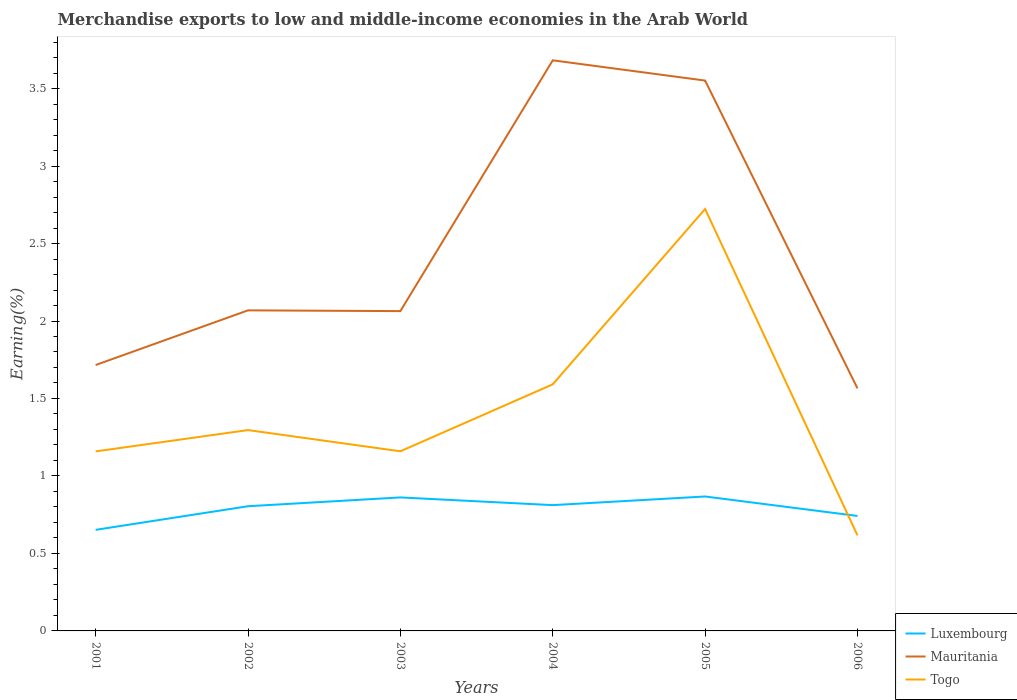How many different coloured lines are there?
Your response must be concise. 3. Does the line corresponding to Luxembourg intersect with the line corresponding to Togo?
Offer a terse response. Yes. Is the number of lines equal to the number of legend labels?
Your answer should be very brief. Yes. Across all years, what is the maximum percentage of amount earned from merchandise exports in Togo?
Your response must be concise. 0.62. What is the total percentage of amount earned from merchandise exports in Luxembourg in the graph?
Give a very brief answer. -0.06. What is the difference between the highest and the second highest percentage of amount earned from merchandise exports in Togo?
Make the answer very short. 2.11. Is the percentage of amount earned from merchandise exports in Mauritania strictly greater than the percentage of amount earned from merchandise exports in Luxembourg over the years?
Keep it short and to the point. No. What is the difference between two consecutive major ticks on the Y-axis?
Give a very brief answer. 0.5. Does the graph contain any zero values?
Make the answer very short. No. Where does the legend appear in the graph?
Offer a very short reply. Bottom right. What is the title of the graph?
Make the answer very short. Merchandise exports to low and middle-income economies in the Arab World. Does "St. Kitts and Nevis" appear as one of the legend labels in the graph?
Your response must be concise. No. What is the label or title of the X-axis?
Offer a terse response. Years. What is the label or title of the Y-axis?
Keep it short and to the point. Earning(%). What is the Earning(%) in Luxembourg in 2001?
Provide a succinct answer. 0.65. What is the Earning(%) of Mauritania in 2001?
Offer a terse response. 1.72. What is the Earning(%) of Togo in 2001?
Provide a short and direct response. 1.16. What is the Earning(%) of Luxembourg in 2002?
Keep it short and to the point. 0.8. What is the Earning(%) of Mauritania in 2002?
Your answer should be compact. 2.07. What is the Earning(%) of Togo in 2002?
Your response must be concise. 1.3. What is the Earning(%) in Luxembourg in 2003?
Provide a succinct answer. 0.86. What is the Earning(%) of Mauritania in 2003?
Ensure brevity in your answer.  2.06. What is the Earning(%) in Togo in 2003?
Offer a terse response. 1.16. What is the Earning(%) of Luxembourg in 2004?
Offer a terse response. 0.81. What is the Earning(%) in Mauritania in 2004?
Your answer should be very brief. 3.68. What is the Earning(%) in Togo in 2004?
Offer a terse response. 1.59. What is the Earning(%) in Luxembourg in 2005?
Keep it short and to the point. 0.87. What is the Earning(%) of Mauritania in 2005?
Your answer should be very brief. 3.55. What is the Earning(%) in Togo in 2005?
Offer a very short reply. 2.72. What is the Earning(%) in Luxembourg in 2006?
Provide a succinct answer. 0.74. What is the Earning(%) of Mauritania in 2006?
Give a very brief answer. 1.57. What is the Earning(%) of Togo in 2006?
Offer a very short reply. 0.62. Across all years, what is the maximum Earning(%) of Luxembourg?
Give a very brief answer. 0.87. Across all years, what is the maximum Earning(%) of Mauritania?
Your answer should be compact. 3.68. Across all years, what is the maximum Earning(%) of Togo?
Provide a short and direct response. 2.72. Across all years, what is the minimum Earning(%) of Luxembourg?
Give a very brief answer. 0.65. Across all years, what is the minimum Earning(%) in Mauritania?
Keep it short and to the point. 1.57. Across all years, what is the minimum Earning(%) of Togo?
Your response must be concise. 0.62. What is the total Earning(%) in Luxembourg in the graph?
Provide a short and direct response. 4.74. What is the total Earning(%) of Mauritania in the graph?
Offer a terse response. 14.65. What is the total Earning(%) of Togo in the graph?
Offer a very short reply. 8.54. What is the difference between the Earning(%) in Luxembourg in 2001 and that in 2002?
Give a very brief answer. -0.15. What is the difference between the Earning(%) of Mauritania in 2001 and that in 2002?
Offer a very short reply. -0.35. What is the difference between the Earning(%) in Togo in 2001 and that in 2002?
Make the answer very short. -0.14. What is the difference between the Earning(%) in Luxembourg in 2001 and that in 2003?
Offer a very short reply. -0.21. What is the difference between the Earning(%) of Mauritania in 2001 and that in 2003?
Provide a short and direct response. -0.35. What is the difference between the Earning(%) in Togo in 2001 and that in 2003?
Make the answer very short. -0. What is the difference between the Earning(%) of Luxembourg in 2001 and that in 2004?
Offer a very short reply. -0.16. What is the difference between the Earning(%) of Mauritania in 2001 and that in 2004?
Provide a short and direct response. -1.97. What is the difference between the Earning(%) of Togo in 2001 and that in 2004?
Provide a succinct answer. -0.43. What is the difference between the Earning(%) of Luxembourg in 2001 and that in 2005?
Your answer should be compact. -0.22. What is the difference between the Earning(%) in Mauritania in 2001 and that in 2005?
Your answer should be compact. -1.84. What is the difference between the Earning(%) in Togo in 2001 and that in 2005?
Give a very brief answer. -1.56. What is the difference between the Earning(%) of Luxembourg in 2001 and that in 2006?
Provide a short and direct response. -0.09. What is the difference between the Earning(%) of Mauritania in 2001 and that in 2006?
Your answer should be compact. 0.15. What is the difference between the Earning(%) of Togo in 2001 and that in 2006?
Offer a very short reply. 0.54. What is the difference between the Earning(%) in Luxembourg in 2002 and that in 2003?
Your answer should be very brief. -0.06. What is the difference between the Earning(%) of Mauritania in 2002 and that in 2003?
Offer a terse response. 0. What is the difference between the Earning(%) in Togo in 2002 and that in 2003?
Offer a terse response. 0.14. What is the difference between the Earning(%) in Luxembourg in 2002 and that in 2004?
Provide a short and direct response. -0.01. What is the difference between the Earning(%) in Mauritania in 2002 and that in 2004?
Provide a succinct answer. -1.61. What is the difference between the Earning(%) in Togo in 2002 and that in 2004?
Give a very brief answer. -0.3. What is the difference between the Earning(%) in Luxembourg in 2002 and that in 2005?
Ensure brevity in your answer.  -0.06. What is the difference between the Earning(%) in Mauritania in 2002 and that in 2005?
Your answer should be compact. -1.48. What is the difference between the Earning(%) of Togo in 2002 and that in 2005?
Your answer should be very brief. -1.43. What is the difference between the Earning(%) of Luxembourg in 2002 and that in 2006?
Offer a very short reply. 0.06. What is the difference between the Earning(%) of Mauritania in 2002 and that in 2006?
Keep it short and to the point. 0.5. What is the difference between the Earning(%) in Togo in 2002 and that in 2006?
Keep it short and to the point. 0.68. What is the difference between the Earning(%) of Luxembourg in 2003 and that in 2004?
Your response must be concise. 0.05. What is the difference between the Earning(%) of Mauritania in 2003 and that in 2004?
Your answer should be compact. -1.62. What is the difference between the Earning(%) of Togo in 2003 and that in 2004?
Your answer should be compact. -0.43. What is the difference between the Earning(%) in Luxembourg in 2003 and that in 2005?
Your answer should be very brief. -0.01. What is the difference between the Earning(%) of Mauritania in 2003 and that in 2005?
Your answer should be compact. -1.49. What is the difference between the Earning(%) of Togo in 2003 and that in 2005?
Ensure brevity in your answer.  -1.56. What is the difference between the Earning(%) of Luxembourg in 2003 and that in 2006?
Provide a succinct answer. 0.12. What is the difference between the Earning(%) in Mauritania in 2003 and that in 2006?
Keep it short and to the point. 0.5. What is the difference between the Earning(%) of Togo in 2003 and that in 2006?
Make the answer very short. 0.54. What is the difference between the Earning(%) of Luxembourg in 2004 and that in 2005?
Keep it short and to the point. -0.06. What is the difference between the Earning(%) of Mauritania in 2004 and that in 2005?
Your answer should be compact. 0.13. What is the difference between the Earning(%) of Togo in 2004 and that in 2005?
Your answer should be very brief. -1.13. What is the difference between the Earning(%) of Luxembourg in 2004 and that in 2006?
Give a very brief answer. 0.07. What is the difference between the Earning(%) of Mauritania in 2004 and that in 2006?
Ensure brevity in your answer.  2.12. What is the difference between the Earning(%) in Togo in 2004 and that in 2006?
Give a very brief answer. 0.97. What is the difference between the Earning(%) of Luxembourg in 2005 and that in 2006?
Offer a very short reply. 0.13. What is the difference between the Earning(%) of Mauritania in 2005 and that in 2006?
Offer a very short reply. 1.99. What is the difference between the Earning(%) of Togo in 2005 and that in 2006?
Provide a short and direct response. 2.11. What is the difference between the Earning(%) of Luxembourg in 2001 and the Earning(%) of Mauritania in 2002?
Ensure brevity in your answer.  -1.42. What is the difference between the Earning(%) in Luxembourg in 2001 and the Earning(%) in Togo in 2002?
Give a very brief answer. -0.64. What is the difference between the Earning(%) in Mauritania in 2001 and the Earning(%) in Togo in 2002?
Keep it short and to the point. 0.42. What is the difference between the Earning(%) in Luxembourg in 2001 and the Earning(%) in Mauritania in 2003?
Your response must be concise. -1.41. What is the difference between the Earning(%) of Luxembourg in 2001 and the Earning(%) of Togo in 2003?
Provide a succinct answer. -0.51. What is the difference between the Earning(%) of Mauritania in 2001 and the Earning(%) of Togo in 2003?
Your response must be concise. 0.56. What is the difference between the Earning(%) of Luxembourg in 2001 and the Earning(%) of Mauritania in 2004?
Give a very brief answer. -3.03. What is the difference between the Earning(%) of Luxembourg in 2001 and the Earning(%) of Togo in 2004?
Make the answer very short. -0.94. What is the difference between the Earning(%) in Mauritania in 2001 and the Earning(%) in Togo in 2004?
Give a very brief answer. 0.12. What is the difference between the Earning(%) in Luxembourg in 2001 and the Earning(%) in Mauritania in 2005?
Make the answer very short. -2.9. What is the difference between the Earning(%) in Luxembourg in 2001 and the Earning(%) in Togo in 2005?
Give a very brief answer. -2.07. What is the difference between the Earning(%) in Mauritania in 2001 and the Earning(%) in Togo in 2005?
Offer a terse response. -1.01. What is the difference between the Earning(%) of Luxembourg in 2001 and the Earning(%) of Mauritania in 2006?
Your response must be concise. -0.91. What is the difference between the Earning(%) of Luxembourg in 2001 and the Earning(%) of Togo in 2006?
Offer a terse response. 0.04. What is the difference between the Earning(%) in Mauritania in 2001 and the Earning(%) in Togo in 2006?
Your answer should be very brief. 1.1. What is the difference between the Earning(%) of Luxembourg in 2002 and the Earning(%) of Mauritania in 2003?
Your answer should be very brief. -1.26. What is the difference between the Earning(%) of Luxembourg in 2002 and the Earning(%) of Togo in 2003?
Keep it short and to the point. -0.35. What is the difference between the Earning(%) in Mauritania in 2002 and the Earning(%) in Togo in 2003?
Provide a succinct answer. 0.91. What is the difference between the Earning(%) of Luxembourg in 2002 and the Earning(%) of Mauritania in 2004?
Provide a short and direct response. -2.88. What is the difference between the Earning(%) of Luxembourg in 2002 and the Earning(%) of Togo in 2004?
Keep it short and to the point. -0.79. What is the difference between the Earning(%) of Mauritania in 2002 and the Earning(%) of Togo in 2004?
Make the answer very short. 0.48. What is the difference between the Earning(%) in Luxembourg in 2002 and the Earning(%) in Mauritania in 2005?
Your response must be concise. -2.75. What is the difference between the Earning(%) in Luxembourg in 2002 and the Earning(%) in Togo in 2005?
Your response must be concise. -1.92. What is the difference between the Earning(%) in Mauritania in 2002 and the Earning(%) in Togo in 2005?
Offer a terse response. -0.65. What is the difference between the Earning(%) in Luxembourg in 2002 and the Earning(%) in Mauritania in 2006?
Your answer should be compact. -0.76. What is the difference between the Earning(%) of Luxembourg in 2002 and the Earning(%) of Togo in 2006?
Offer a terse response. 0.19. What is the difference between the Earning(%) of Mauritania in 2002 and the Earning(%) of Togo in 2006?
Provide a succinct answer. 1.45. What is the difference between the Earning(%) in Luxembourg in 2003 and the Earning(%) in Mauritania in 2004?
Ensure brevity in your answer.  -2.82. What is the difference between the Earning(%) in Luxembourg in 2003 and the Earning(%) in Togo in 2004?
Give a very brief answer. -0.73. What is the difference between the Earning(%) of Mauritania in 2003 and the Earning(%) of Togo in 2004?
Your answer should be compact. 0.47. What is the difference between the Earning(%) of Luxembourg in 2003 and the Earning(%) of Mauritania in 2005?
Offer a terse response. -2.69. What is the difference between the Earning(%) in Luxembourg in 2003 and the Earning(%) in Togo in 2005?
Ensure brevity in your answer.  -1.86. What is the difference between the Earning(%) in Mauritania in 2003 and the Earning(%) in Togo in 2005?
Make the answer very short. -0.66. What is the difference between the Earning(%) in Luxembourg in 2003 and the Earning(%) in Mauritania in 2006?
Your response must be concise. -0.7. What is the difference between the Earning(%) of Luxembourg in 2003 and the Earning(%) of Togo in 2006?
Offer a very short reply. 0.24. What is the difference between the Earning(%) of Mauritania in 2003 and the Earning(%) of Togo in 2006?
Your response must be concise. 1.45. What is the difference between the Earning(%) in Luxembourg in 2004 and the Earning(%) in Mauritania in 2005?
Your answer should be very brief. -2.74. What is the difference between the Earning(%) of Luxembourg in 2004 and the Earning(%) of Togo in 2005?
Keep it short and to the point. -1.91. What is the difference between the Earning(%) of Mauritania in 2004 and the Earning(%) of Togo in 2005?
Provide a short and direct response. 0.96. What is the difference between the Earning(%) of Luxembourg in 2004 and the Earning(%) of Mauritania in 2006?
Keep it short and to the point. -0.75. What is the difference between the Earning(%) in Luxembourg in 2004 and the Earning(%) in Togo in 2006?
Your answer should be compact. 0.2. What is the difference between the Earning(%) of Mauritania in 2004 and the Earning(%) of Togo in 2006?
Your answer should be compact. 3.07. What is the difference between the Earning(%) of Luxembourg in 2005 and the Earning(%) of Mauritania in 2006?
Offer a terse response. -0.7. What is the difference between the Earning(%) of Luxembourg in 2005 and the Earning(%) of Togo in 2006?
Offer a terse response. 0.25. What is the difference between the Earning(%) in Mauritania in 2005 and the Earning(%) in Togo in 2006?
Your response must be concise. 2.93. What is the average Earning(%) of Luxembourg per year?
Provide a short and direct response. 0.79. What is the average Earning(%) of Mauritania per year?
Make the answer very short. 2.44. What is the average Earning(%) in Togo per year?
Offer a very short reply. 1.42. In the year 2001, what is the difference between the Earning(%) in Luxembourg and Earning(%) in Mauritania?
Ensure brevity in your answer.  -1.06. In the year 2001, what is the difference between the Earning(%) of Luxembourg and Earning(%) of Togo?
Provide a short and direct response. -0.51. In the year 2001, what is the difference between the Earning(%) of Mauritania and Earning(%) of Togo?
Your answer should be very brief. 0.56. In the year 2002, what is the difference between the Earning(%) in Luxembourg and Earning(%) in Mauritania?
Ensure brevity in your answer.  -1.26. In the year 2002, what is the difference between the Earning(%) in Luxembourg and Earning(%) in Togo?
Provide a succinct answer. -0.49. In the year 2002, what is the difference between the Earning(%) of Mauritania and Earning(%) of Togo?
Your answer should be very brief. 0.77. In the year 2003, what is the difference between the Earning(%) in Luxembourg and Earning(%) in Mauritania?
Provide a short and direct response. -1.2. In the year 2003, what is the difference between the Earning(%) of Luxembourg and Earning(%) of Togo?
Keep it short and to the point. -0.3. In the year 2003, what is the difference between the Earning(%) in Mauritania and Earning(%) in Togo?
Offer a terse response. 0.9. In the year 2004, what is the difference between the Earning(%) of Luxembourg and Earning(%) of Mauritania?
Provide a short and direct response. -2.87. In the year 2004, what is the difference between the Earning(%) in Luxembourg and Earning(%) in Togo?
Your answer should be very brief. -0.78. In the year 2004, what is the difference between the Earning(%) in Mauritania and Earning(%) in Togo?
Your answer should be compact. 2.09. In the year 2005, what is the difference between the Earning(%) of Luxembourg and Earning(%) of Mauritania?
Keep it short and to the point. -2.68. In the year 2005, what is the difference between the Earning(%) in Luxembourg and Earning(%) in Togo?
Keep it short and to the point. -1.86. In the year 2005, what is the difference between the Earning(%) of Mauritania and Earning(%) of Togo?
Give a very brief answer. 0.83. In the year 2006, what is the difference between the Earning(%) in Luxembourg and Earning(%) in Mauritania?
Keep it short and to the point. -0.82. In the year 2006, what is the difference between the Earning(%) in Luxembourg and Earning(%) in Togo?
Ensure brevity in your answer.  0.13. In the year 2006, what is the difference between the Earning(%) of Mauritania and Earning(%) of Togo?
Provide a succinct answer. 0.95. What is the ratio of the Earning(%) of Luxembourg in 2001 to that in 2002?
Provide a succinct answer. 0.81. What is the ratio of the Earning(%) in Mauritania in 2001 to that in 2002?
Offer a terse response. 0.83. What is the ratio of the Earning(%) of Togo in 2001 to that in 2002?
Your answer should be compact. 0.89. What is the ratio of the Earning(%) in Luxembourg in 2001 to that in 2003?
Keep it short and to the point. 0.76. What is the ratio of the Earning(%) in Mauritania in 2001 to that in 2003?
Provide a short and direct response. 0.83. What is the ratio of the Earning(%) of Togo in 2001 to that in 2003?
Provide a short and direct response. 1. What is the ratio of the Earning(%) of Luxembourg in 2001 to that in 2004?
Keep it short and to the point. 0.8. What is the ratio of the Earning(%) of Mauritania in 2001 to that in 2004?
Offer a very short reply. 0.47. What is the ratio of the Earning(%) in Togo in 2001 to that in 2004?
Ensure brevity in your answer.  0.73. What is the ratio of the Earning(%) in Luxembourg in 2001 to that in 2005?
Your response must be concise. 0.75. What is the ratio of the Earning(%) of Mauritania in 2001 to that in 2005?
Your answer should be very brief. 0.48. What is the ratio of the Earning(%) of Togo in 2001 to that in 2005?
Make the answer very short. 0.43. What is the ratio of the Earning(%) of Luxembourg in 2001 to that in 2006?
Provide a short and direct response. 0.88. What is the ratio of the Earning(%) of Mauritania in 2001 to that in 2006?
Provide a succinct answer. 1.1. What is the ratio of the Earning(%) of Togo in 2001 to that in 2006?
Your answer should be very brief. 1.88. What is the ratio of the Earning(%) in Luxembourg in 2002 to that in 2003?
Keep it short and to the point. 0.93. What is the ratio of the Earning(%) of Togo in 2002 to that in 2003?
Keep it short and to the point. 1.12. What is the ratio of the Earning(%) of Mauritania in 2002 to that in 2004?
Make the answer very short. 0.56. What is the ratio of the Earning(%) in Togo in 2002 to that in 2004?
Keep it short and to the point. 0.81. What is the ratio of the Earning(%) of Luxembourg in 2002 to that in 2005?
Give a very brief answer. 0.93. What is the ratio of the Earning(%) in Mauritania in 2002 to that in 2005?
Provide a succinct answer. 0.58. What is the ratio of the Earning(%) of Togo in 2002 to that in 2005?
Your answer should be compact. 0.48. What is the ratio of the Earning(%) in Luxembourg in 2002 to that in 2006?
Provide a short and direct response. 1.08. What is the ratio of the Earning(%) of Mauritania in 2002 to that in 2006?
Your answer should be compact. 1.32. What is the ratio of the Earning(%) in Togo in 2002 to that in 2006?
Your answer should be very brief. 2.1. What is the ratio of the Earning(%) of Luxembourg in 2003 to that in 2004?
Ensure brevity in your answer.  1.06. What is the ratio of the Earning(%) of Mauritania in 2003 to that in 2004?
Your answer should be compact. 0.56. What is the ratio of the Earning(%) in Togo in 2003 to that in 2004?
Provide a succinct answer. 0.73. What is the ratio of the Earning(%) in Luxembourg in 2003 to that in 2005?
Your answer should be compact. 0.99. What is the ratio of the Earning(%) in Mauritania in 2003 to that in 2005?
Offer a very short reply. 0.58. What is the ratio of the Earning(%) in Togo in 2003 to that in 2005?
Ensure brevity in your answer.  0.43. What is the ratio of the Earning(%) of Luxembourg in 2003 to that in 2006?
Offer a terse response. 1.16. What is the ratio of the Earning(%) of Mauritania in 2003 to that in 2006?
Provide a short and direct response. 1.32. What is the ratio of the Earning(%) of Togo in 2003 to that in 2006?
Offer a terse response. 1.88. What is the ratio of the Earning(%) of Luxembourg in 2004 to that in 2005?
Your answer should be very brief. 0.94. What is the ratio of the Earning(%) in Mauritania in 2004 to that in 2005?
Keep it short and to the point. 1.04. What is the ratio of the Earning(%) in Togo in 2004 to that in 2005?
Give a very brief answer. 0.58. What is the ratio of the Earning(%) in Luxembourg in 2004 to that in 2006?
Give a very brief answer. 1.09. What is the ratio of the Earning(%) of Mauritania in 2004 to that in 2006?
Give a very brief answer. 2.35. What is the ratio of the Earning(%) of Togo in 2004 to that in 2006?
Your response must be concise. 2.58. What is the ratio of the Earning(%) in Luxembourg in 2005 to that in 2006?
Offer a very short reply. 1.17. What is the ratio of the Earning(%) of Mauritania in 2005 to that in 2006?
Your response must be concise. 2.27. What is the ratio of the Earning(%) in Togo in 2005 to that in 2006?
Provide a short and direct response. 4.41. What is the difference between the highest and the second highest Earning(%) in Luxembourg?
Give a very brief answer. 0.01. What is the difference between the highest and the second highest Earning(%) in Mauritania?
Your answer should be very brief. 0.13. What is the difference between the highest and the second highest Earning(%) in Togo?
Your response must be concise. 1.13. What is the difference between the highest and the lowest Earning(%) in Luxembourg?
Ensure brevity in your answer.  0.22. What is the difference between the highest and the lowest Earning(%) in Mauritania?
Offer a very short reply. 2.12. What is the difference between the highest and the lowest Earning(%) of Togo?
Offer a very short reply. 2.11. 